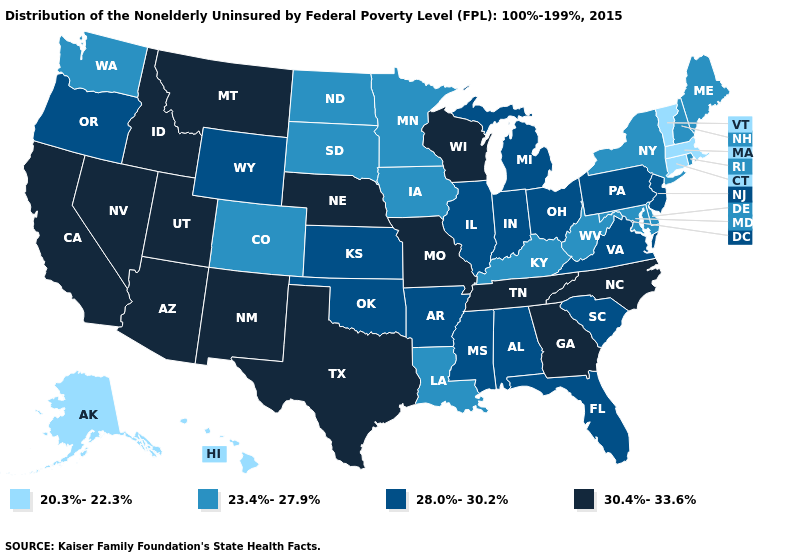What is the lowest value in states that border Indiana?
Short answer required. 23.4%-27.9%. Name the states that have a value in the range 28.0%-30.2%?
Keep it brief. Alabama, Arkansas, Florida, Illinois, Indiana, Kansas, Michigan, Mississippi, New Jersey, Ohio, Oklahoma, Oregon, Pennsylvania, South Carolina, Virginia, Wyoming. Does Virginia have the lowest value in the South?
Answer briefly. No. Name the states that have a value in the range 28.0%-30.2%?
Quick response, please. Alabama, Arkansas, Florida, Illinois, Indiana, Kansas, Michigan, Mississippi, New Jersey, Ohio, Oklahoma, Oregon, Pennsylvania, South Carolina, Virginia, Wyoming. Among the states that border North Dakota , does Minnesota have the highest value?
Keep it brief. No. What is the lowest value in the USA?
Answer briefly. 20.3%-22.3%. What is the value of New Jersey?
Give a very brief answer. 28.0%-30.2%. Name the states that have a value in the range 30.4%-33.6%?
Concise answer only. Arizona, California, Georgia, Idaho, Missouri, Montana, Nebraska, Nevada, New Mexico, North Carolina, Tennessee, Texas, Utah, Wisconsin. Which states hav the highest value in the MidWest?
Concise answer only. Missouri, Nebraska, Wisconsin. What is the value of Tennessee?
Short answer required. 30.4%-33.6%. What is the highest value in the USA?
Quick response, please. 30.4%-33.6%. What is the value of Iowa?
Quick response, please. 23.4%-27.9%. Does Arkansas have the lowest value in the USA?
Concise answer only. No. What is the lowest value in the MidWest?
Answer briefly. 23.4%-27.9%. What is the value of Nevada?
Be succinct. 30.4%-33.6%. 